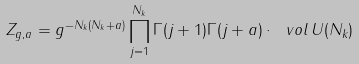Convert formula to latex. <formula><loc_0><loc_0><loc_500><loc_500>Z _ { g , a } = g ^ { - N _ { k } ( N _ { k } + a ) } \prod _ { j = 1 } ^ { N _ { k } } \Gamma ( j + 1 ) \Gamma ( j + a ) \cdot \ v o l \, U ( N _ { k } )</formula> 